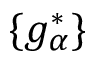Convert formula to latex. <formula><loc_0><loc_0><loc_500><loc_500>\{ g _ { \alpha } ^ { * } \}</formula> 